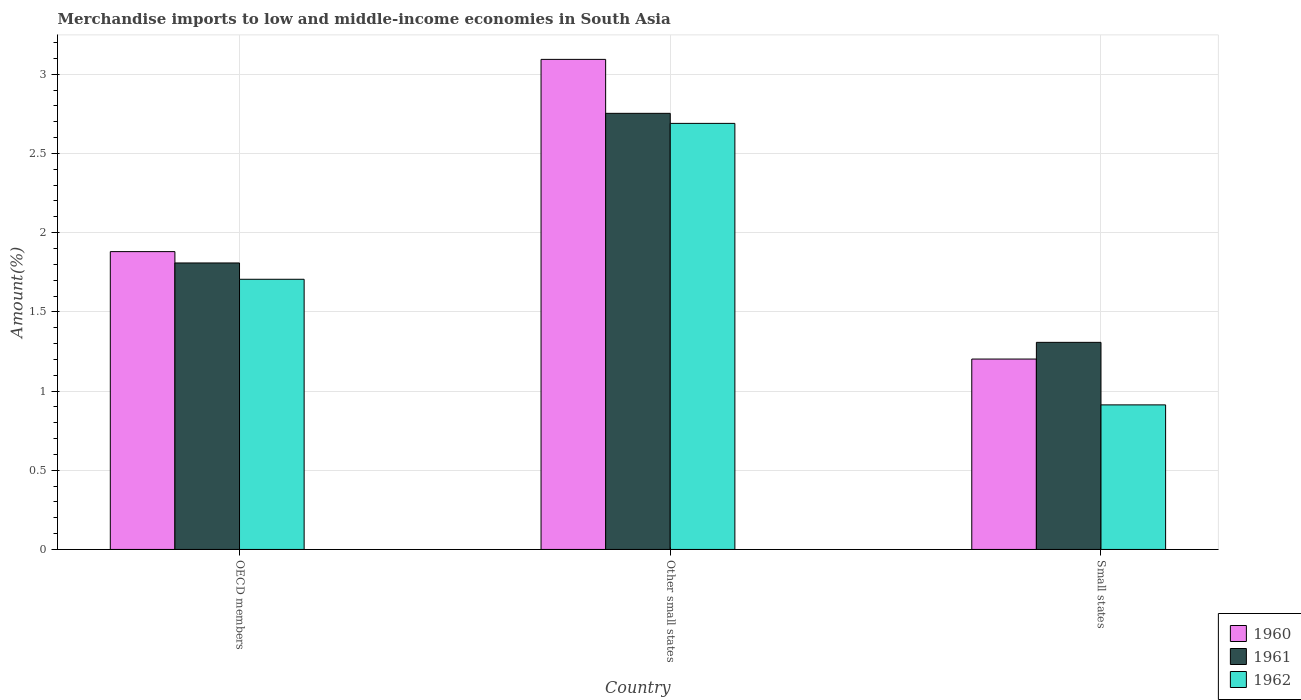Are the number of bars per tick equal to the number of legend labels?
Give a very brief answer. Yes. Are the number of bars on each tick of the X-axis equal?
Your answer should be compact. Yes. How many bars are there on the 3rd tick from the left?
Make the answer very short. 3. How many bars are there on the 2nd tick from the right?
Provide a short and direct response. 3. What is the label of the 3rd group of bars from the left?
Your answer should be compact. Small states. In how many cases, is the number of bars for a given country not equal to the number of legend labels?
Offer a terse response. 0. What is the percentage of amount earned from merchandise imports in 1962 in OECD members?
Your response must be concise. 1.71. Across all countries, what is the maximum percentage of amount earned from merchandise imports in 1962?
Your response must be concise. 2.69. Across all countries, what is the minimum percentage of amount earned from merchandise imports in 1962?
Provide a short and direct response. 0.91. In which country was the percentage of amount earned from merchandise imports in 1961 maximum?
Ensure brevity in your answer.  Other small states. In which country was the percentage of amount earned from merchandise imports in 1961 minimum?
Provide a succinct answer. Small states. What is the total percentage of amount earned from merchandise imports in 1962 in the graph?
Offer a terse response. 5.31. What is the difference between the percentage of amount earned from merchandise imports in 1962 in OECD members and that in Other small states?
Keep it short and to the point. -0.98. What is the difference between the percentage of amount earned from merchandise imports in 1962 in OECD members and the percentage of amount earned from merchandise imports in 1960 in Other small states?
Your answer should be very brief. -1.39. What is the average percentage of amount earned from merchandise imports in 1961 per country?
Your response must be concise. 1.96. What is the difference between the percentage of amount earned from merchandise imports of/in 1962 and percentage of amount earned from merchandise imports of/in 1961 in OECD members?
Your response must be concise. -0.1. In how many countries, is the percentage of amount earned from merchandise imports in 1960 greater than 2.3 %?
Keep it short and to the point. 1. What is the ratio of the percentage of amount earned from merchandise imports in 1962 in OECD members to that in Other small states?
Keep it short and to the point. 0.63. What is the difference between the highest and the second highest percentage of amount earned from merchandise imports in 1961?
Ensure brevity in your answer.  -0.94. What is the difference between the highest and the lowest percentage of amount earned from merchandise imports in 1962?
Provide a succinct answer. 1.78. In how many countries, is the percentage of amount earned from merchandise imports in 1962 greater than the average percentage of amount earned from merchandise imports in 1962 taken over all countries?
Offer a terse response. 1. Is the sum of the percentage of amount earned from merchandise imports in 1960 in OECD members and Small states greater than the maximum percentage of amount earned from merchandise imports in 1962 across all countries?
Ensure brevity in your answer.  Yes. Is it the case that in every country, the sum of the percentage of amount earned from merchandise imports in 1962 and percentage of amount earned from merchandise imports in 1960 is greater than the percentage of amount earned from merchandise imports in 1961?
Offer a very short reply. Yes. How many bars are there?
Give a very brief answer. 9. Are all the bars in the graph horizontal?
Make the answer very short. No. What is the difference between two consecutive major ticks on the Y-axis?
Offer a very short reply. 0.5. Are the values on the major ticks of Y-axis written in scientific E-notation?
Give a very brief answer. No. Does the graph contain any zero values?
Your answer should be compact. No. How are the legend labels stacked?
Give a very brief answer. Vertical. What is the title of the graph?
Give a very brief answer. Merchandise imports to low and middle-income economies in South Asia. What is the label or title of the X-axis?
Your answer should be very brief. Country. What is the label or title of the Y-axis?
Make the answer very short. Amount(%). What is the Amount(%) of 1960 in OECD members?
Ensure brevity in your answer.  1.88. What is the Amount(%) in 1961 in OECD members?
Provide a short and direct response. 1.81. What is the Amount(%) of 1962 in OECD members?
Make the answer very short. 1.71. What is the Amount(%) in 1960 in Other small states?
Your answer should be compact. 3.09. What is the Amount(%) in 1961 in Other small states?
Your answer should be very brief. 2.75. What is the Amount(%) in 1962 in Other small states?
Offer a very short reply. 2.69. What is the Amount(%) of 1960 in Small states?
Your answer should be compact. 1.2. What is the Amount(%) in 1961 in Small states?
Your answer should be compact. 1.31. What is the Amount(%) of 1962 in Small states?
Provide a short and direct response. 0.91. Across all countries, what is the maximum Amount(%) in 1960?
Keep it short and to the point. 3.09. Across all countries, what is the maximum Amount(%) in 1961?
Your response must be concise. 2.75. Across all countries, what is the maximum Amount(%) in 1962?
Keep it short and to the point. 2.69. Across all countries, what is the minimum Amount(%) of 1960?
Your answer should be very brief. 1.2. Across all countries, what is the minimum Amount(%) of 1961?
Offer a very short reply. 1.31. Across all countries, what is the minimum Amount(%) of 1962?
Offer a terse response. 0.91. What is the total Amount(%) in 1960 in the graph?
Your response must be concise. 6.18. What is the total Amount(%) in 1961 in the graph?
Offer a very short reply. 5.87. What is the total Amount(%) in 1962 in the graph?
Provide a succinct answer. 5.31. What is the difference between the Amount(%) of 1960 in OECD members and that in Other small states?
Offer a very short reply. -1.21. What is the difference between the Amount(%) of 1961 in OECD members and that in Other small states?
Give a very brief answer. -0.94. What is the difference between the Amount(%) of 1962 in OECD members and that in Other small states?
Your answer should be compact. -0.98. What is the difference between the Amount(%) of 1960 in OECD members and that in Small states?
Make the answer very short. 0.68. What is the difference between the Amount(%) of 1961 in OECD members and that in Small states?
Your response must be concise. 0.5. What is the difference between the Amount(%) of 1962 in OECD members and that in Small states?
Provide a succinct answer. 0.79. What is the difference between the Amount(%) in 1960 in Other small states and that in Small states?
Offer a very short reply. 1.89. What is the difference between the Amount(%) of 1961 in Other small states and that in Small states?
Your response must be concise. 1.45. What is the difference between the Amount(%) in 1962 in Other small states and that in Small states?
Your answer should be very brief. 1.78. What is the difference between the Amount(%) in 1960 in OECD members and the Amount(%) in 1961 in Other small states?
Your answer should be compact. -0.87. What is the difference between the Amount(%) of 1960 in OECD members and the Amount(%) of 1962 in Other small states?
Provide a succinct answer. -0.81. What is the difference between the Amount(%) in 1961 in OECD members and the Amount(%) in 1962 in Other small states?
Provide a short and direct response. -0.88. What is the difference between the Amount(%) in 1960 in OECD members and the Amount(%) in 1961 in Small states?
Make the answer very short. 0.57. What is the difference between the Amount(%) in 1960 in OECD members and the Amount(%) in 1962 in Small states?
Offer a terse response. 0.97. What is the difference between the Amount(%) in 1961 in OECD members and the Amount(%) in 1962 in Small states?
Your response must be concise. 0.9. What is the difference between the Amount(%) in 1960 in Other small states and the Amount(%) in 1961 in Small states?
Offer a very short reply. 1.79. What is the difference between the Amount(%) in 1960 in Other small states and the Amount(%) in 1962 in Small states?
Your answer should be very brief. 2.18. What is the difference between the Amount(%) of 1961 in Other small states and the Amount(%) of 1962 in Small states?
Offer a terse response. 1.84. What is the average Amount(%) in 1960 per country?
Ensure brevity in your answer.  2.06. What is the average Amount(%) in 1961 per country?
Your response must be concise. 1.96. What is the average Amount(%) of 1962 per country?
Offer a terse response. 1.77. What is the difference between the Amount(%) of 1960 and Amount(%) of 1961 in OECD members?
Your response must be concise. 0.07. What is the difference between the Amount(%) of 1960 and Amount(%) of 1962 in OECD members?
Ensure brevity in your answer.  0.17. What is the difference between the Amount(%) of 1961 and Amount(%) of 1962 in OECD members?
Keep it short and to the point. 0.1. What is the difference between the Amount(%) in 1960 and Amount(%) in 1961 in Other small states?
Provide a succinct answer. 0.34. What is the difference between the Amount(%) of 1960 and Amount(%) of 1962 in Other small states?
Your answer should be compact. 0.4. What is the difference between the Amount(%) in 1961 and Amount(%) in 1962 in Other small states?
Keep it short and to the point. 0.06. What is the difference between the Amount(%) of 1960 and Amount(%) of 1961 in Small states?
Keep it short and to the point. -0.11. What is the difference between the Amount(%) of 1960 and Amount(%) of 1962 in Small states?
Make the answer very short. 0.29. What is the difference between the Amount(%) in 1961 and Amount(%) in 1962 in Small states?
Ensure brevity in your answer.  0.39. What is the ratio of the Amount(%) in 1960 in OECD members to that in Other small states?
Provide a succinct answer. 0.61. What is the ratio of the Amount(%) of 1961 in OECD members to that in Other small states?
Keep it short and to the point. 0.66. What is the ratio of the Amount(%) of 1962 in OECD members to that in Other small states?
Give a very brief answer. 0.63. What is the ratio of the Amount(%) in 1960 in OECD members to that in Small states?
Keep it short and to the point. 1.56. What is the ratio of the Amount(%) of 1961 in OECD members to that in Small states?
Your answer should be very brief. 1.38. What is the ratio of the Amount(%) in 1962 in OECD members to that in Small states?
Your response must be concise. 1.87. What is the ratio of the Amount(%) of 1960 in Other small states to that in Small states?
Ensure brevity in your answer.  2.57. What is the ratio of the Amount(%) in 1961 in Other small states to that in Small states?
Ensure brevity in your answer.  2.11. What is the ratio of the Amount(%) in 1962 in Other small states to that in Small states?
Provide a short and direct response. 2.95. What is the difference between the highest and the second highest Amount(%) of 1960?
Provide a short and direct response. 1.21. What is the difference between the highest and the second highest Amount(%) in 1961?
Offer a terse response. 0.94. What is the difference between the highest and the second highest Amount(%) of 1962?
Provide a short and direct response. 0.98. What is the difference between the highest and the lowest Amount(%) of 1960?
Your answer should be compact. 1.89. What is the difference between the highest and the lowest Amount(%) of 1961?
Offer a very short reply. 1.45. What is the difference between the highest and the lowest Amount(%) of 1962?
Keep it short and to the point. 1.78. 